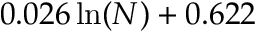Convert formula to latex. <formula><loc_0><loc_0><loc_500><loc_500>0 . 0 2 6 \, \ln ( N ) + 0 . 6 2 2</formula> 